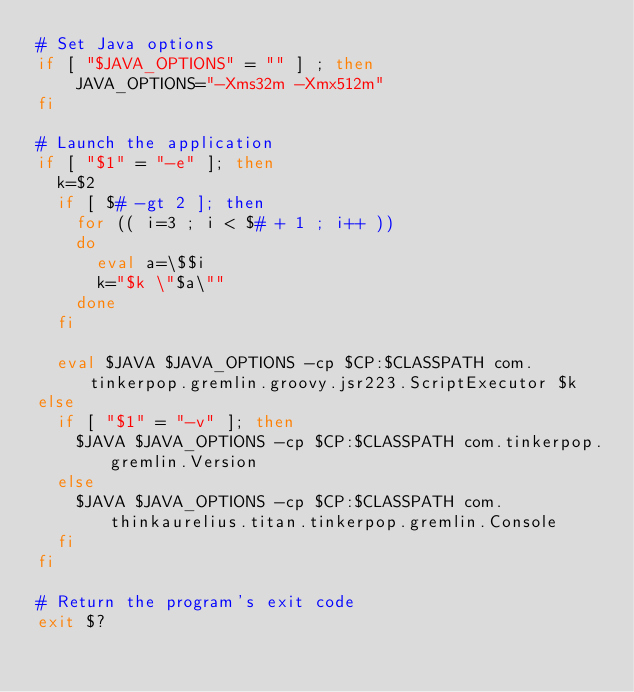<code> <loc_0><loc_0><loc_500><loc_500><_Bash_># Set Java options
if [ "$JAVA_OPTIONS" = "" ] ; then
    JAVA_OPTIONS="-Xms32m -Xmx512m"
fi

# Launch the application
if [ "$1" = "-e" ]; then
  k=$2
  if [ $# -gt 2 ]; then
    for (( i=3 ; i < $# + 1 ; i++ ))
    do
      eval a=\$$i
      k="$k \"$a\""
    done
  fi

  eval $JAVA $JAVA_OPTIONS -cp $CP:$CLASSPATH com.tinkerpop.gremlin.groovy.jsr223.ScriptExecutor $k
else
  if [ "$1" = "-v" ]; then
    $JAVA $JAVA_OPTIONS -cp $CP:$CLASSPATH com.tinkerpop.gremlin.Version
  else
    $JAVA $JAVA_OPTIONS -cp $CP:$CLASSPATH com.thinkaurelius.titan.tinkerpop.gremlin.Console
  fi
fi

# Return the program's exit code
exit $?</code> 